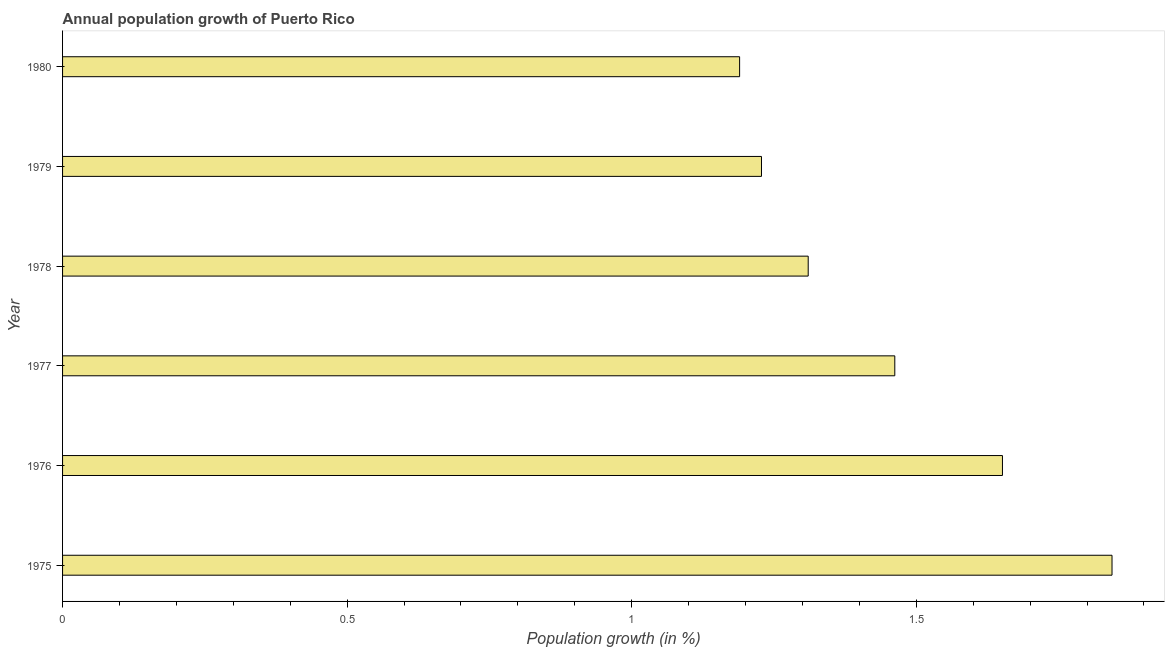Does the graph contain grids?
Provide a short and direct response. No. What is the title of the graph?
Offer a very short reply. Annual population growth of Puerto Rico. What is the label or title of the X-axis?
Give a very brief answer. Population growth (in %). What is the label or title of the Y-axis?
Your answer should be compact. Year. What is the population growth in 1979?
Offer a terse response. 1.23. Across all years, what is the maximum population growth?
Offer a terse response. 1.84. Across all years, what is the minimum population growth?
Your answer should be compact. 1.19. In which year was the population growth maximum?
Your answer should be compact. 1975. What is the sum of the population growth?
Offer a terse response. 8.69. What is the difference between the population growth in 1975 and 1978?
Give a very brief answer. 0.53. What is the average population growth per year?
Offer a terse response. 1.45. What is the median population growth?
Provide a succinct answer. 1.39. In how many years, is the population growth greater than 0.6 %?
Give a very brief answer. 6. Do a majority of the years between 1980 and 1978 (inclusive) have population growth greater than 0.4 %?
Keep it short and to the point. Yes. What is the ratio of the population growth in 1978 to that in 1979?
Offer a very short reply. 1.07. What is the difference between the highest and the second highest population growth?
Provide a succinct answer. 0.19. What is the difference between the highest and the lowest population growth?
Offer a terse response. 0.65. In how many years, is the population growth greater than the average population growth taken over all years?
Your response must be concise. 3. What is the Population growth (in %) in 1975?
Keep it short and to the point. 1.84. What is the Population growth (in %) of 1976?
Offer a very short reply. 1.65. What is the Population growth (in %) in 1977?
Keep it short and to the point. 1.46. What is the Population growth (in %) of 1978?
Give a very brief answer. 1.31. What is the Population growth (in %) in 1979?
Your answer should be very brief. 1.23. What is the Population growth (in %) of 1980?
Offer a very short reply. 1.19. What is the difference between the Population growth (in %) in 1975 and 1976?
Offer a terse response. 0.19. What is the difference between the Population growth (in %) in 1975 and 1977?
Your answer should be very brief. 0.38. What is the difference between the Population growth (in %) in 1975 and 1978?
Make the answer very short. 0.53. What is the difference between the Population growth (in %) in 1975 and 1979?
Offer a terse response. 0.62. What is the difference between the Population growth (in %) in 1975 and 1980?
Keep it short and to the point. 0.65. What is the difference between the Population growth (in %) in 1976 and 1977?
Offer a very short reply. 0.19. What is the difference between the Population growth (in %) in 1976 and 1978?
Make the answer very short. 0.34. What is the difference between the Population growth (in %) in 1976 and 1979?
Provide a short and direct response. 0.42. What is the difference between the Population growth (in %) in 1976 and 1980?
Ensure brevity in your answer.  0.46. What is the difference between the Population growth (in %) in 1977 and 1978?
Your response must be concise. 0.15. What is the difference between the Population growth (in %) in 1977 and 1979?
Make the answer very short. 0.23. What is the difference between the Population growth (in %) in 1977 and 1980?
Make the answer very short. 0.27. What is the difference between the Population growth (in %) in 1978 and 1979?
Provide a succinct answer. 0.08. What is the difference between the Population growth (in %) in 1978 and 1980?
Offer a very short reply. 0.12. What is the difference between the Population growth (in %) in 1979 and 1980?
Provide a short and direct response. 0.04. What is the ratio of the Population growth (in %) in 1975 to that in 1976?
Provide a succinct answer. 1.12. What is the ratio of the Population growth (in %) in 1975 to that in 1977?
Provide a succinct answer. 1.26. What is the ratio of the Population growth (in %) in 1975 to that in 1978?
Give a very brief answer. 1.41. What is the ratio of the Population growth (in %) in 1975 to that in 1979?
Offer a very short reply. 1.5. What is the ratio of the Population growth (in %) in 1975 to that in 1980?
Provide a succinct answer. 1.55. What is the ratio of the Population growth (in %) in 1976 to that in 1977?
Give a very brief answer. 1.13. What is the ratio of the Population growth (in %) in 1976 to that in 1978?
Provide a succinct answer. 1.26. What is the ratio of the Population growth (in %) in 1976 to that in 1979?
Ensure brevity in your answer.  1.34. What is the ratio of the Population growth (in %) in 1976 to that in 1980?
Provide a short and direct response. 1.39. What is the ratio of the Population growth (in %) in 1977 to that in 1978?
Provide a succinct answer. 1.12. What is the ratio of the Population growth (in %) in 1977 to that in 1979?
Provide a short and direct response. 1.19. What is the ratio of the Population growth (in %) in 1977 to that in 1980?
Offer a terse response. 1.23. What is the ratio of the Population growth (in %) in 1978 to that in 1979?
Provide a succinct answer. 1.07. What is the ratio of the Population growth (in %) in 1978 to that in 1980?
Provide a short and direct response. 1.1. What is the ratio of the Population growth (in %) in 1979 to that in 1980?
Your response must be concise. 1.03. 